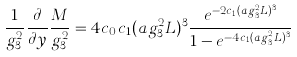<formula> <loc_0><loc_0><loc_500><loc_500>\frac { 1 } { g _ { 3 } ^ { 2 } } \frac { \partial } { \partial y } \frac { M } { g _ { 3 } ^ { 2 } } = 4 c _ { 0 } c _ { 1 } ( a g _ { 3 } ^ { 2 } L ) ^ { 3 } \frac { e ^ { - 2 c _ { 1 } ( a g _ { 3 } ^ { 2 } L ) ^ { 3 } } } { 1 - e ^ { - 4 c _ { 1 } ( a g _ { 3 } ^ { 2 } L ) ^ { 3 } } }</formula> 